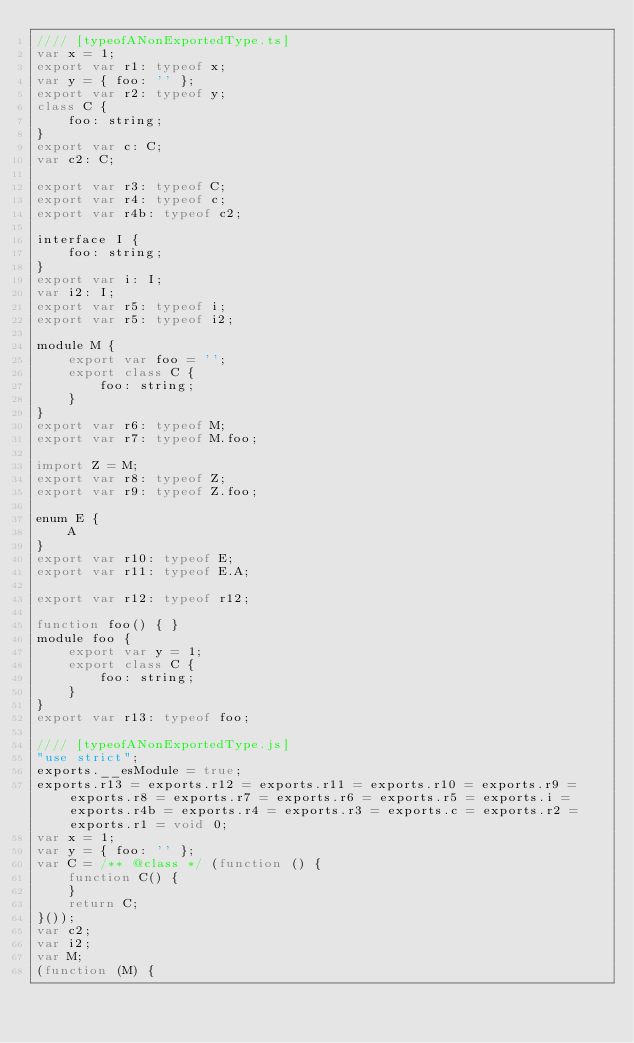Convert code to text. <code><loc_0><loc_0><loc_500><loc_500><_JavaScript_>//// [typeofANonExportedType.ts]
var x = 1;
export var r1: typeof x;
var y = { foo: '' };
export var r2: typeof y;
class C {
    foo: string;
}
export var c: C;
var c2: C;

export var r3: typeof C;
export var r4: typeof c;
export var r4b: typeof c2;

interface I {
    foo: string;
}
export var i: I;
var i2: I;
export var r5: typeof i;
export var r5: typeof i2;

module M {
    export var foo = '';
    export class C {
        foo: string;
    }
}
export var r6: typeof M;
export var r7: typeof M.foo;

import Z = M;
export var r8: typeof Z;
export var r9: typeof Z.foo;

enum E {
    A
}
export var r10: typeof E;
export var r11: typeof E.A;

export var r12: typeof r12;

function foo() { }
module foo {
    export var y = 1;
    export class C {
        foo: string;
    }
}
export var r13: typeof foo;

//// [typeofANonExportedType.js]
"use strict";
exports.__esModule = true;
exports.r13 = exports.r12 = exports.r11 = exports.r10 = exports.r9 = exports.r8 = exports.r7 = exports.r6 = exports.r5 = exports.i = exports.r4b = exports.r4 = exports.r3 = exports.c = exports.r2 = exports.r1 = void 0;
var x = 1;
var y = { foo: '' };
var C = /** @class */ (function () {
    function C() {
    }
    return C;
}());
var c2;
var i2;
var M;
(function (M) {</code> 